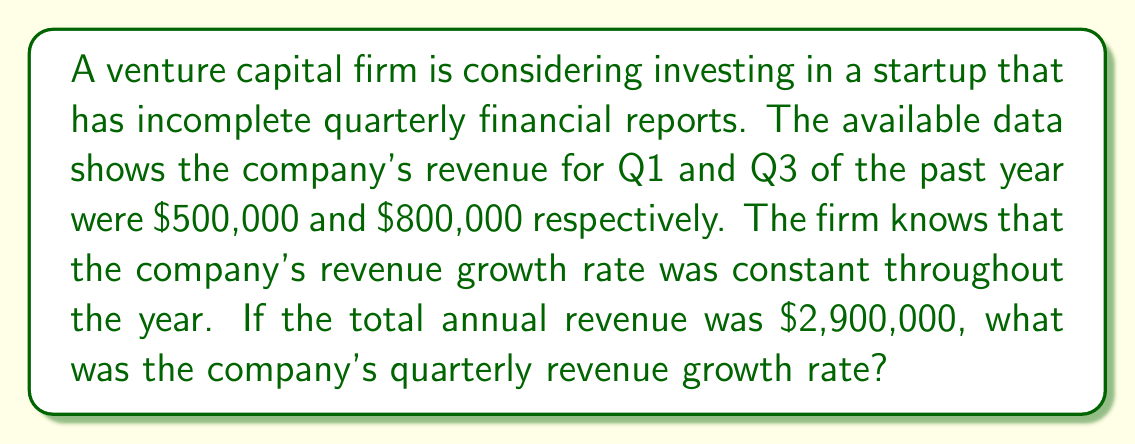Teach me how to tackle this problem. Let's approach this step-by-step:

1) Let's denote the quarterly growth rate as $r$. This means each quarter's revenue is $r$ times the previous quarter's revenue.

2) Given the information, we can set up the following equations:
   Q1 revenue: $500,000
   Q2 revenue: $500,000 * r
   Q3 revenue: $500,000 * r^2 = 800,000
   Q4 revenue: $500,000 * r^3

3) From the Q3 equation, we can derive:
   $r^2 = 800,000 / 500,000 = 1.6$
   $r = \sqrt{1.6} \approx 1.2649$

4) Now, let's verify if this growth rate results in the given total annual revenue:
   Total Revenue = $500,000 + 500,000r + 500,000r^2 + 500,000r^3$
                 = $500,000(1 + r + r^2 + r^3)$
                 = $500,000(1 + 1.2649 + 1.6 + 1.6 * 1.2649)$
                 = $500,000(5.8298)$
                 = $2,914,900$

5) This is very close to the given total of $2,900,000, with the small difference likely due to rounding.

6) To express the growth rate as a percentage, we subtract 1 from $r$ and multiply by 100:
   Growth rate = $(1.2649 - 1) * 100 = 26.49\%$
Answer: $26.49\%$ 